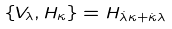<formula> <loc_0><loc_0><loc_500><loc_500>\{ V _ { \lambda } , H _ { \kappa } \} = H _ { \dot { \lambda } \kappa + \dot { \kappa } \lambda }</formula> 